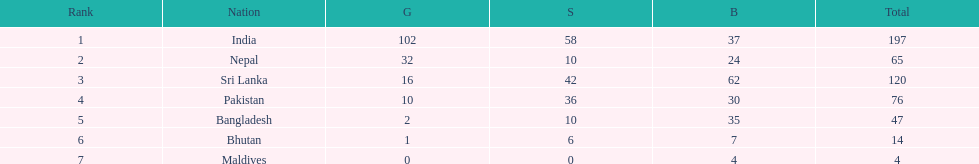What is the difference between the nation with the most medals and the nation with the least amount of medals? 193. Could you parse the entire table? {'header': ['Rank', 'Nation', 'G', 'S', 'B', 'Total'], 'rows': [['1', 'India', '102', '58', '37', '197'], ['2', 'Nepal', '32', '10', '24', '65'], ['3', 'Sri Lanka', '16', '42', '62', '120'], ['4', 'Pakistan', '10', '36', '30', '76'], ['5', 'Bangladesh', '2', '10', '35', '47'], ['6', 'Bhutan', '1', '6', '7', '14'], ['7', 'Maldives', '0', '0', '4', '4']]} 